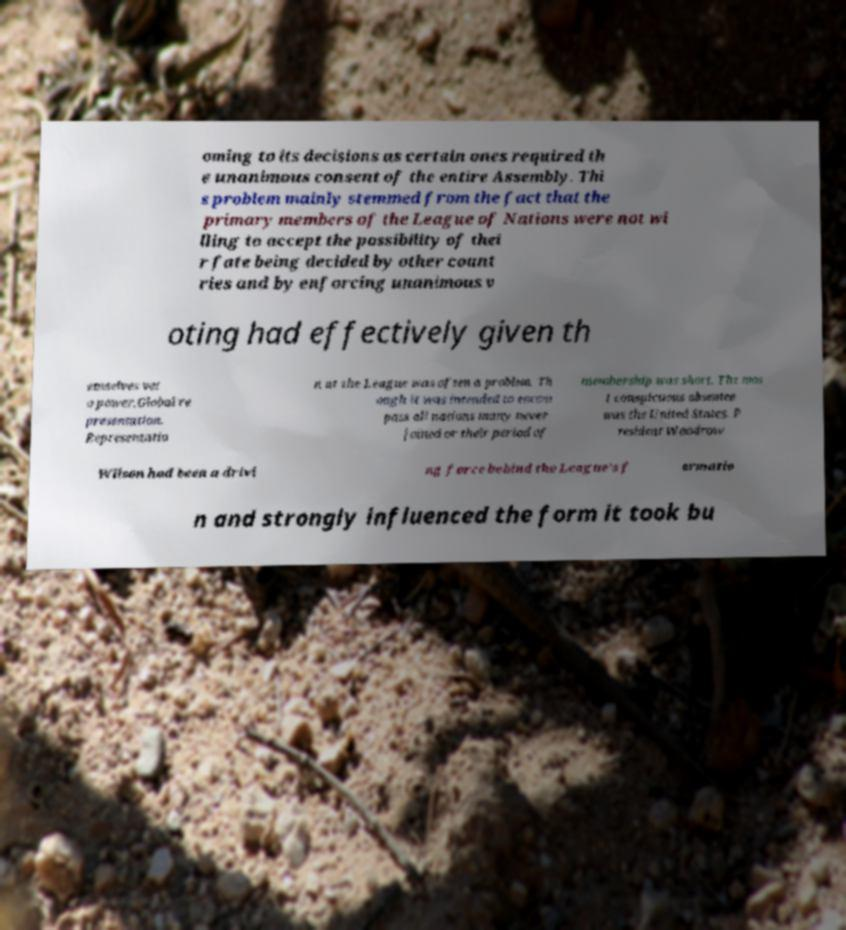Can you accurately transcribe the text from the provided image for me? oming to its decisions as certain ones required th e unanimous consent of the entire Assembly. Thi s problem mainly stemmed from the fact that the primary members of the League of Nations were not wi lling to accept the possibility of thei r fate being decided by other count ries and by enforcing unanimous v oting had effectively given th emselves vet o power.Global re presentation. Representatio n at the League was often a problem. Th ough it was intended to encom pass all nations many never joined or their period of membership was short. The mos t conspicuous absentee was the United States. P resident Woodrow Wilson had been a drivi ng force behind the League's f ormatio n and strongly influenced the form it took bu 